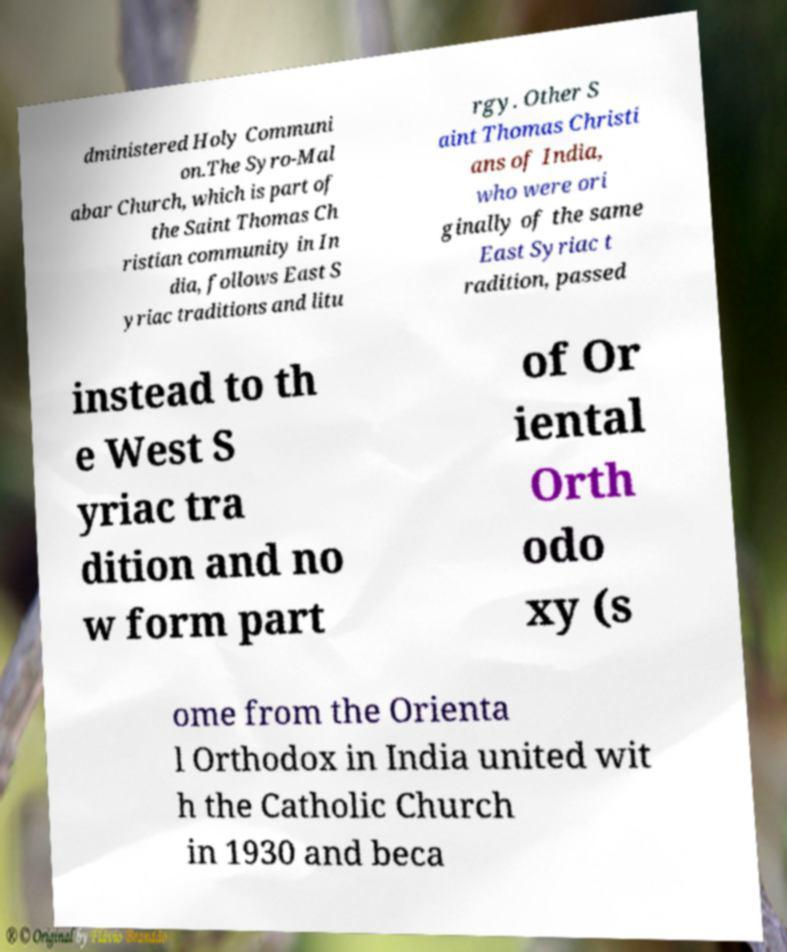There's text embedded in this image that I need extracted. Can you transcribe it verbatim? dministered Holy Communi on.The Syro-Mal abar Church, which is part of the Saint Thomas Ch ristian community in In dia, follows East S yriac traditions and litu rgy. Other S aint Thomas Christi ans of India, who were ori ginally of the same East Syriac t radition, passed instead to th e West S yriac tra dition and no w form part of Or iental Orth odo xy (s ome from the Orienta l Orthodox in India united wit h the Catholic Church in 1930 and beca 